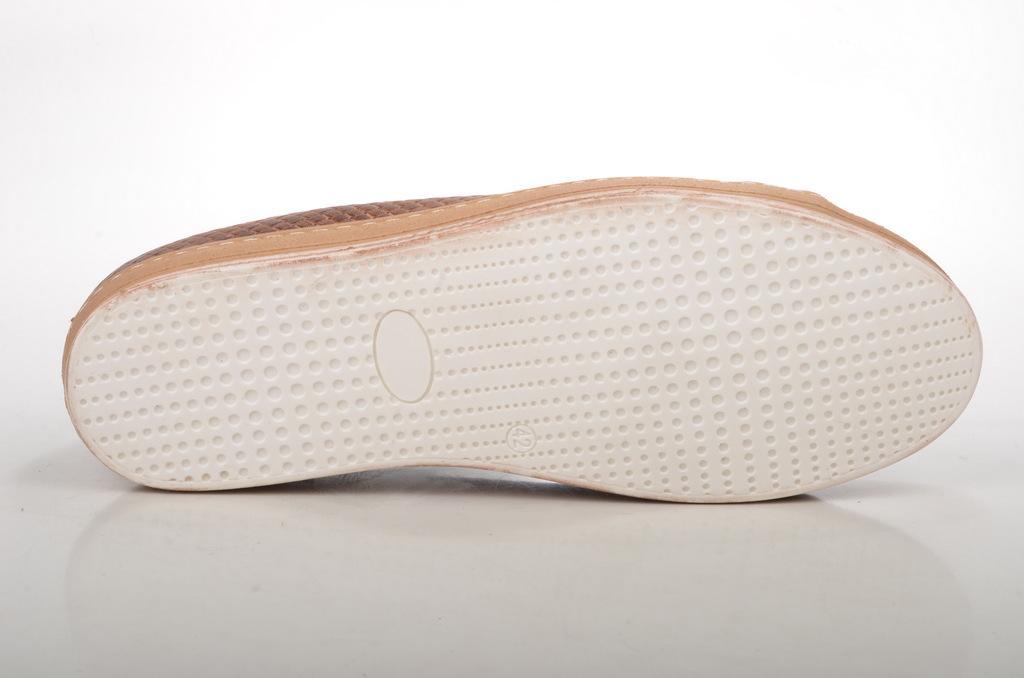How would you summarize this image in a sentence or two? Here in this picture we can see a shoe present on the floor over there. 